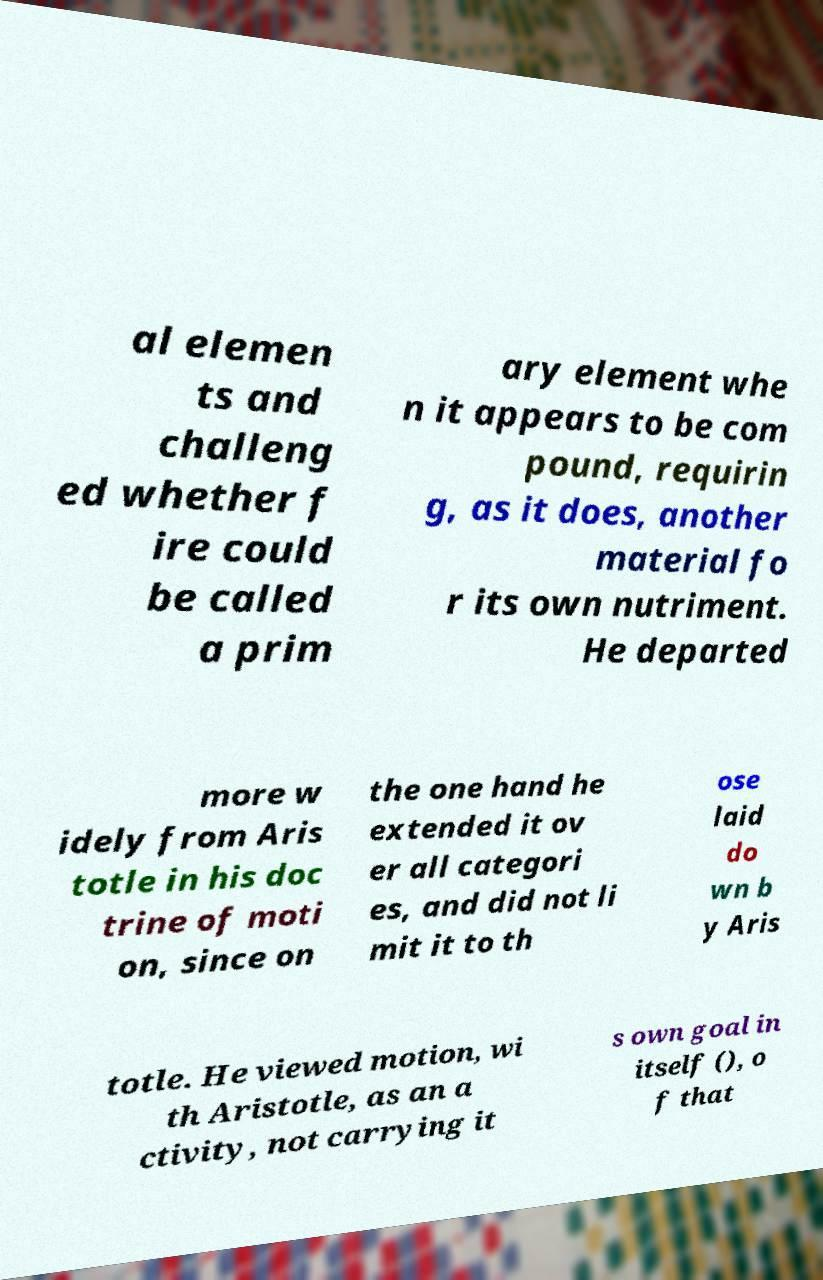For documentation purposes, I need the text within this image transcribed. Could you provide that? al elemen ts and challeng ed whether f ire could be called a prim ary element whe n it appears to be com pound, requirin g, as it does, another material fo r its own nutriment. He departed more w idely from Aris totle in his doc trine of moti on, since on the one hand he extended it ov er all categori es, and did not li mit it to th ose laid do wn b y Aris totle. He viewed motion, wi th Aristotle, as an a ctivity, not carrying it s own goal in itself (), o f that 